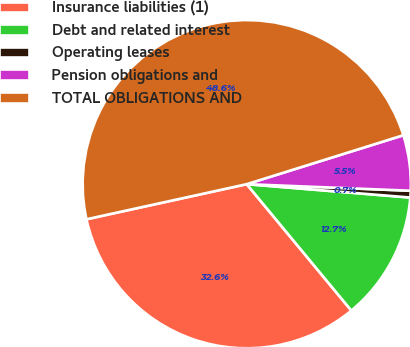Convert chart. <chart><loc_0><loc_0><loc_500><loc_500><pie_chart><fcel>Insurance liabilities (1)<fcel>Debt and related interest<fcel>Operating leases<fcel>Pension obligations and<fcel>TOTAL OBLIGATIONS AND<nl><fcel>32.57%<fcel>12.7%<fcel>0.66%<fcel>5.46%<fcel>48.61%<nl></chart> 